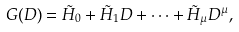<formula> <loc_0><loc_0><loc_500><loc_500>G ( D ) = \tilde { H } _ { 0 } + \tilde { H } _ { 1 } D + \cdots + \tilde { H } _ { \mu } D ^ { \mu } ,</formula> 